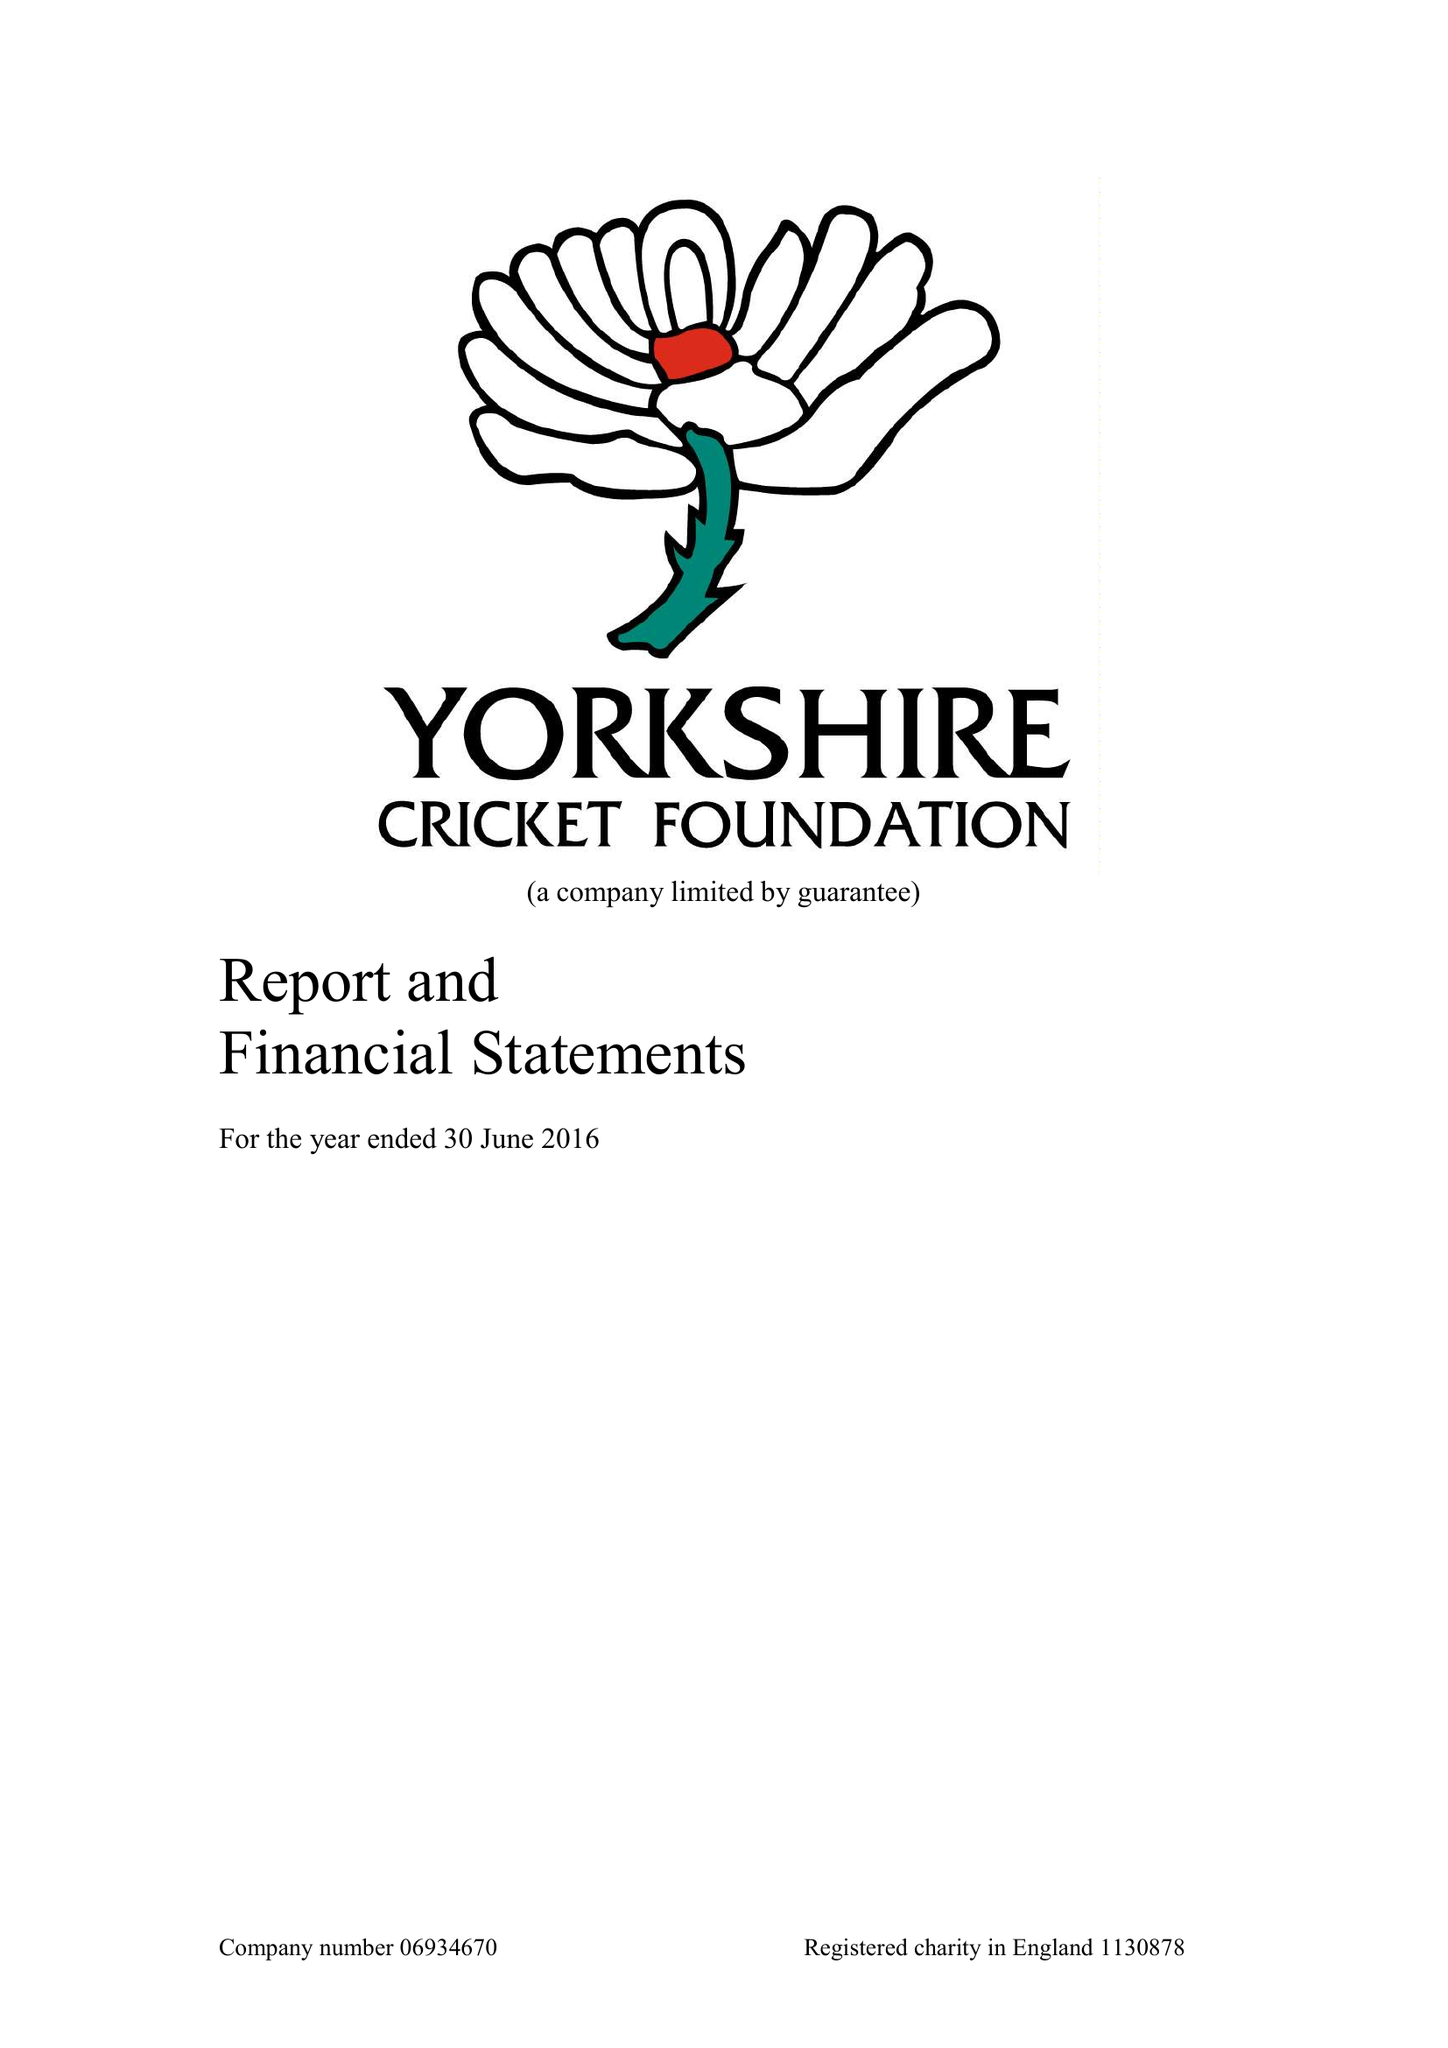What is the value for the charity_number?
Answer the question using a single word or phrase. 1130878 